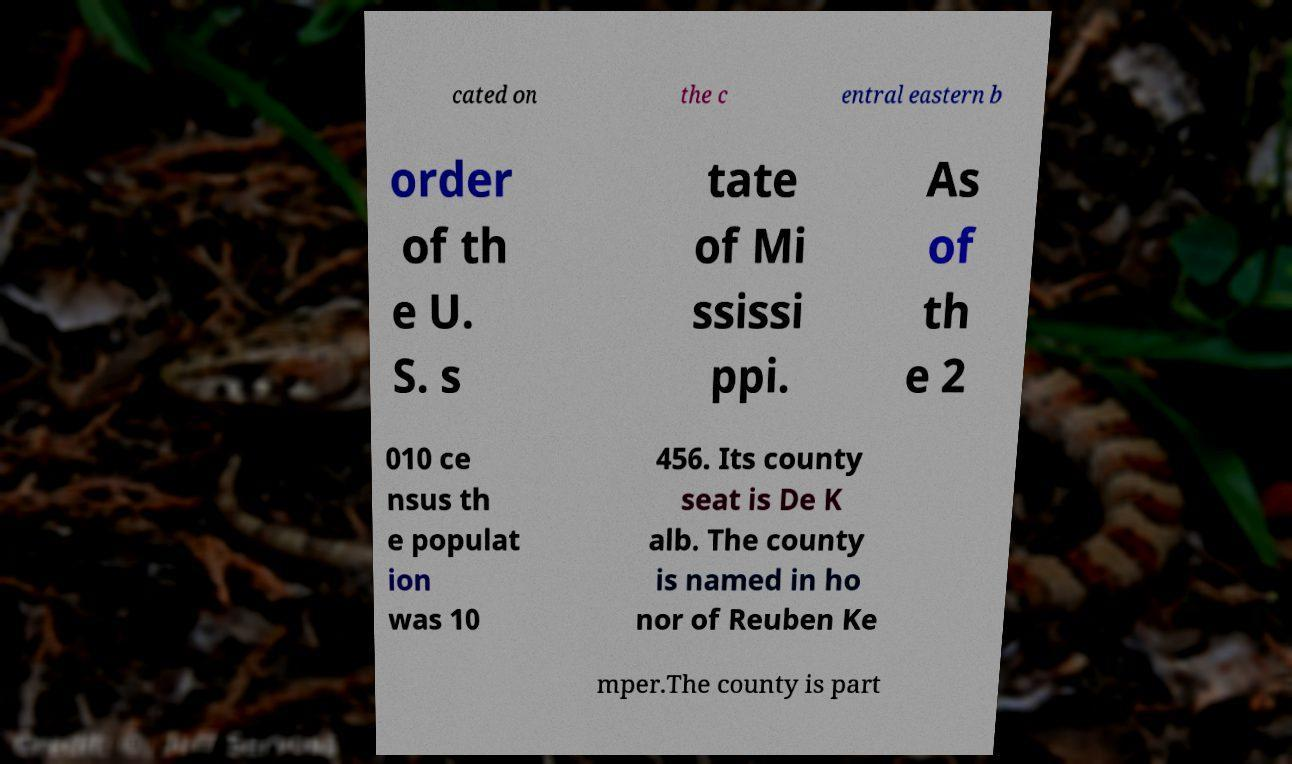Can you accurately transcribe the text from the provided image for me? cated on the c entral eastern b order of th e U. S. s tate of Mi ssissi ppi. As of th e 2 010 ce nsus th e populat ion was 10 456. Its county seat is De K alb. The county is named in ho nor of Reuben Ke mper.The county is part 